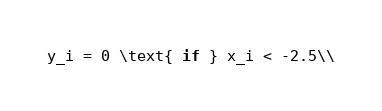<code> <loc_0><loc_0><loc_500><loc_500><_C++_>y_i = 0 \text{ if } x_i < -2.5\\</code> 